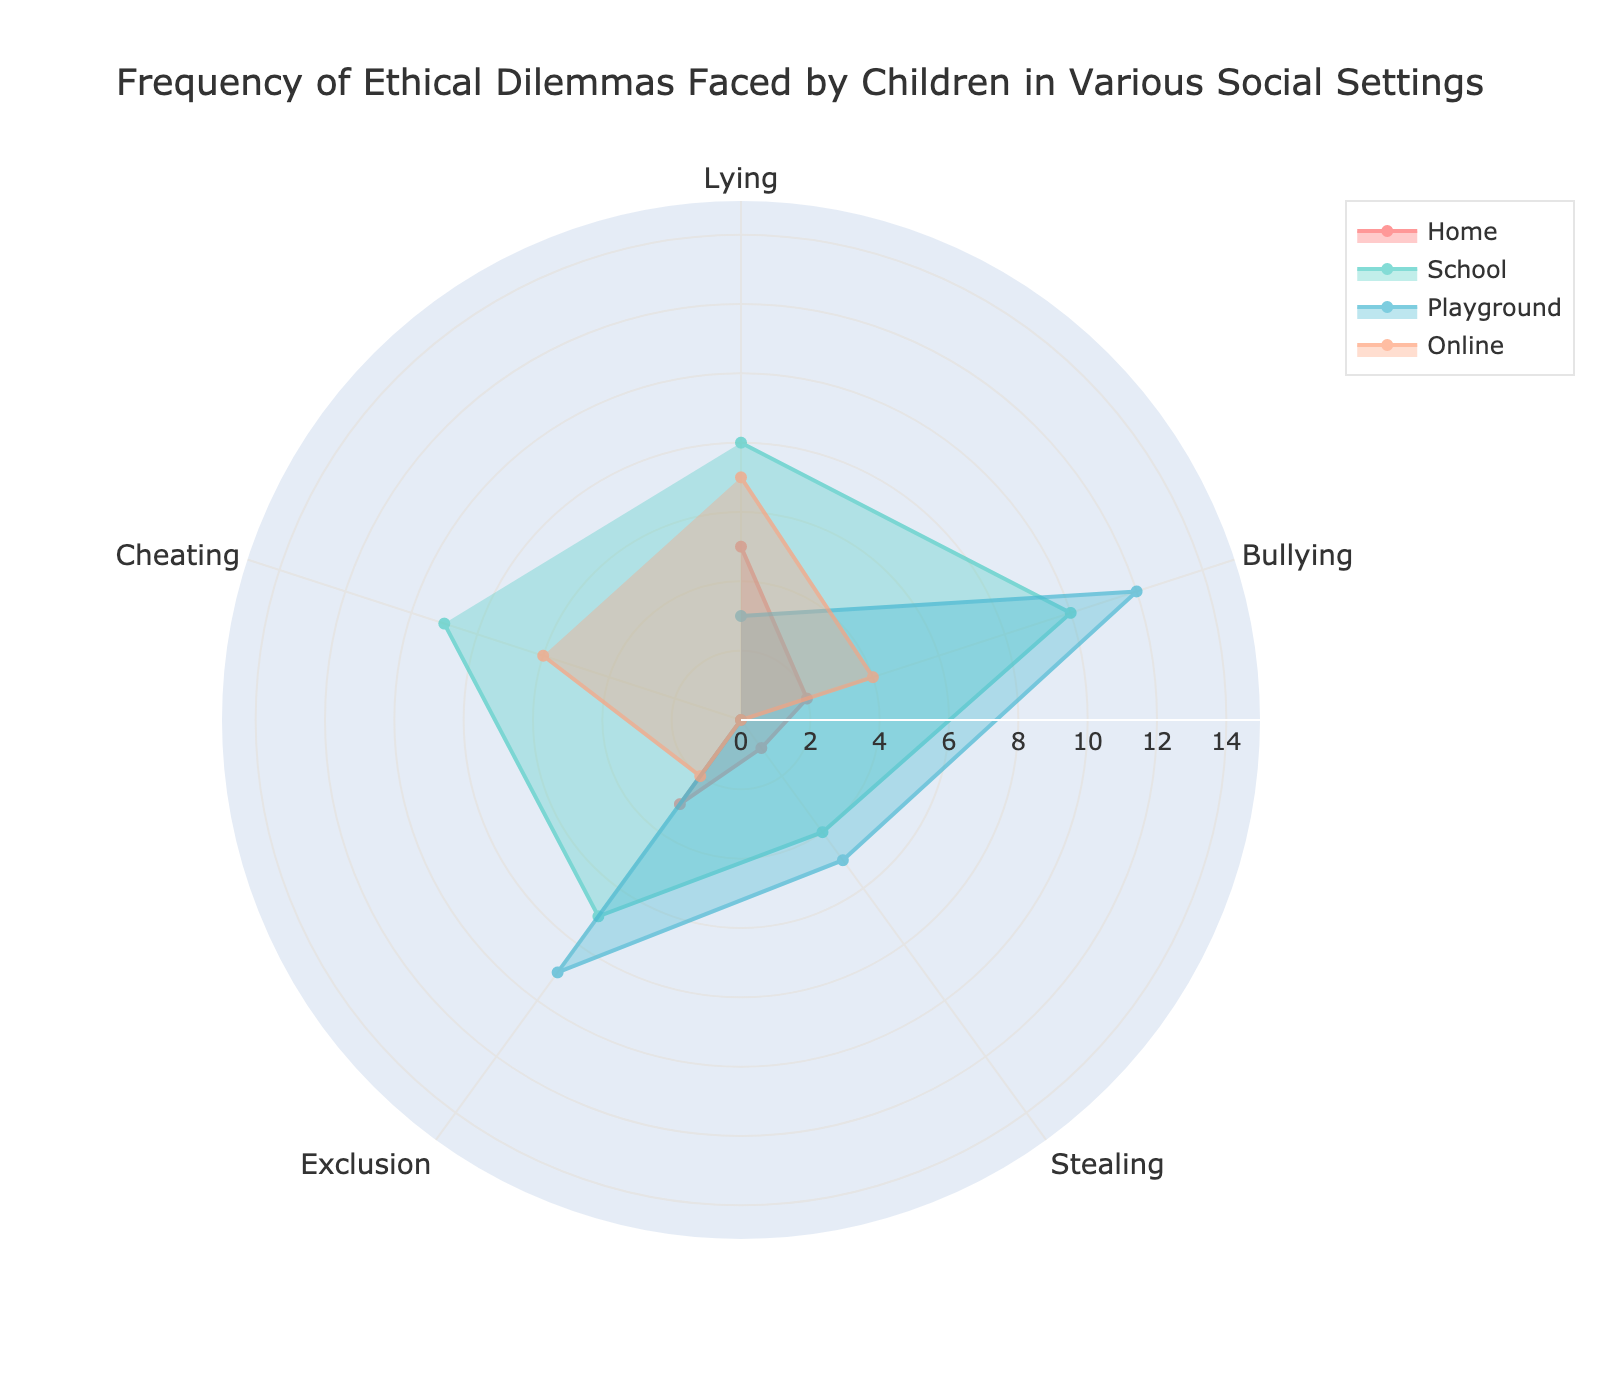What is the title of the plot? The title is prominently displayed at the top of the figure. It provides an overview of what the plot represents.
Answer: Frequency of Ethical Dilemmas Faced by Children in Various Social Settings Which social setting shows the highest frequency of bullying cases? To find the answer, look at the "Bullying" category and compare the radial values for each social setting (Home, School, Playground, Online). Identify the setting with the longest radial line.
Answer: Playground How many ethical dilemmas are reported in the Home setting for Cheating and Exclusion combined? Add the frequencies for Cheating and Exclusion in the Home setting from the polar chart. This involves referring to the respective angles and summing the values.
Answer: 3 Which category shows no reports of ethical dilemmas in a specific setting? Check each category section for any zero values. Identify the category and its corresponding setting.
Answer: Cheating, Home Compare the frequency of Lying in School and Online settings. Which has more reported cases and by how much? Find the radial values for Lying in both School and Online settings. Subtract the smaller value from the larger one to get the difference.
Answer: School has 1 more case than Online What is the average frequency of reported cases for Bullying across all settings? Sum the frequencies of Bullying across Home, School, Playground, and Online settings. Then divide by the number of settings (4) to find the average.
Answer: 7 Which ethical dilemma shows the largest disparity in reported cases across different settings? Examine the range of values for each ethical dilemma category. Identify the category with the largest difference between the highest and lowest values.
Answer: Bullying In which setting is the frequency of Exclusion highest? Look at the "Exclusion" category and compare the radial values for Home, School, Playground, and Online settings. Identify the setting with the longest radial line.
Answer: Playground How many data points are represented in the figure for each setting? Count the number of categories (angles) represented for each social setting. Each setting has the same number of data points, corresponding to the number of ethical dilemmas.
Answer: 5 What changes in frequency between School and Home for the Stealing category? Identify and subtract the frequency of Stealing in the Home setting from that in the School setting to determine the change.
Answer: Increases by 3 